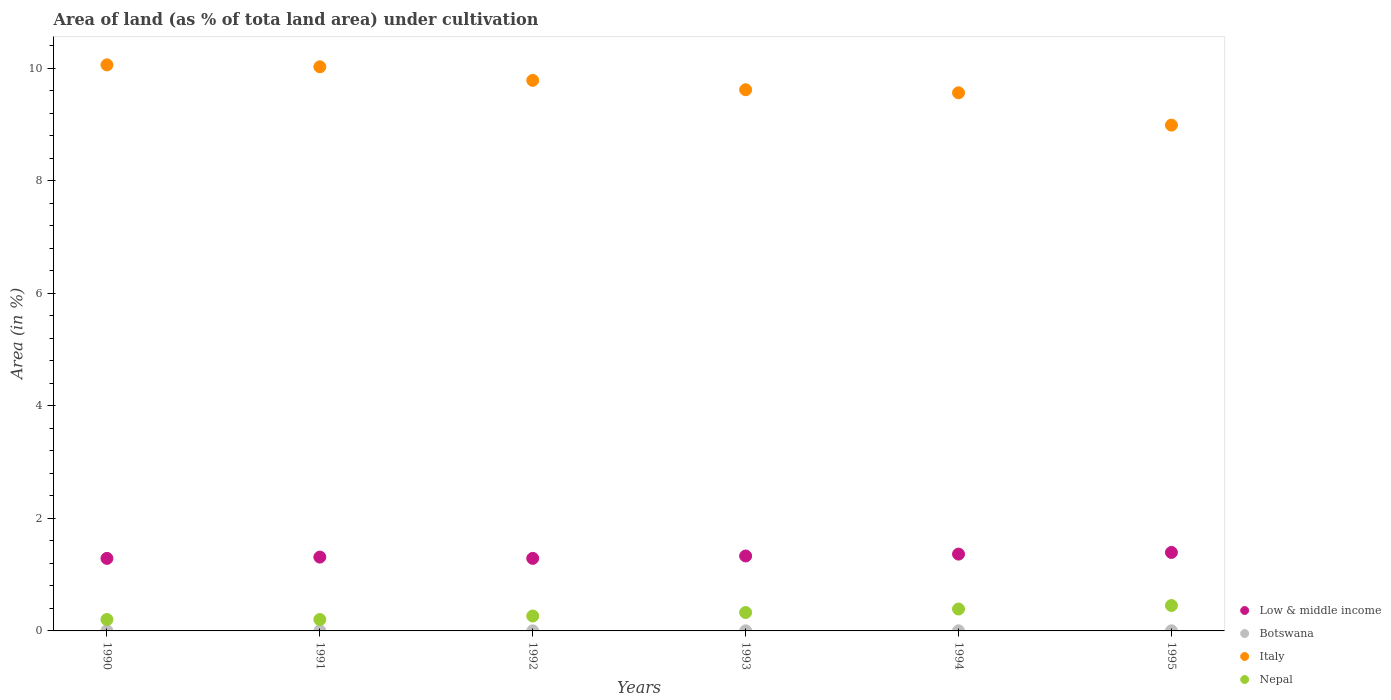How many different coloured dotlines are there?
Make the answer very short. 4. What is the percentage of land under cultivation in Botswana in 1990?
Provide a short and direct response. 0. Across all years, what is the maximum percentage of land under cultivation in Italy?
Keep it short and to the point. 10.06. Across all years, what is the minimum percentage of land under cultivation in Italy?
Your answer should be compact. 8.99. In which year was the percentage of land under cultivation in Nepal maximum?
Offer a very short reply. 1995. In which year was the percentage of land under cultivation in Low & middle income minimum?
Your response must be concise. 1990. What is the total percentage of land under cultivation in Italy in the graph?
Provide a short and direct response. 58.07. What is the difference between the percentage of land under cultivation in Nepal in 1991 and that in 1993?
Offer a terse response. -0.12. What is the difference between the percentage of land under cultivation in Botswana in 1993 and the percentage of land under cultivation in Low & middle income in 1994?
Provide a succinct answer. -1.36. What is the average percentage of land under cultivation in Low & middle income per year?
Provide a short and direct response. 1.33. In the year 1991, what is the difference between the percentage of land under cultivation in Italy and percentage of land under cultivation in Low & middle income?
Provide a short and direct response. 8.72. What is the ratio of the percentage of land under cultivation in Nepal in 1994 to that in 1995?
Give a very brief answer. 0.86. Is the difference between the percentage of land under cultivation in Italy in 1994 and 1995 greater than the difference between the percentage of land under cultivation in Low & middle income in 1994 and 1995?
Provide a succinct answer. Yes. What is the difference between the highest and the second highest percentage of land under cultivation in Nepal?
Give a very brief answer. 0.06. What is the difference between the highest and the lowest percentage of land under cultivation in Botswana?
Provide a succinct answer. 0. Is it the case that in every year, the sum of the percentage of land under cultivation in Nepal and percentage of land under cultivation in Italy  is greater than the sum of percentage of land under cultivation in Low & middle income and percentage of land under cultivation in Botswana?
Your answer should be very brief. Yes. Is it the case that in every year, the sum of the percentage of land under cultivation in Low & middle income and percentage of land under cultivation in Italy  is greater than the percentage of land under cultivation in Nepal?
Your answer should be compact. Yes. How many dotlines are there?
Ensure brevity in your answer.  4. Does the graph contain any zero values?
Give a very brief answer. No. Does the graph contain grids?
Your answer should be compact. No. Where does the legend appear in the graph?
Your answer should be compact. Bottom right. How many legend labels are there?
Keep it short and to the point. 4. How are the legend labels stacked?
Provide a succinct answer. Vertical. What is the title of the graph?
Offer a terse response. Area of land (as % of tota land area) under cultivation. What is the label or title of the X-axis?
Your answer should be compact. Years. What is the label or title of the Y-axis?
Provide a short and direct response. Area (in %). What is the Area (in %) in Low & middle income in 1990?
Your answer should be very brief. 1.29. What is the Area (in %) in Botswana in 1990?
Offer a very short reply. 0. What is the Area (in %) in Italy in 1990?
Your answer should be very brief. 10.06. What is the Area (in %) in Nepal in 1990?
Your answer should be compact. 0.2. What is the Area (in %) of Low & middle income in 1991?
Offer a very short reply. 1.31. What is the Area (in %) in Botswana in 1991?
Give a very brief answer. 0. What is the Area (in %) in Italy in 1991?
Offer a very short reply. 10.03. What is the Area (in %) of Nepal in 1991?
Keep it short and to the point. 0.2. What is the Area (in %) in Low & middle income in 1992?
Your answer should be very brief. 1.29. What is the Area (in %) in Botswana in 1992?
Provide a succinct answer. 0. What is the Area (in %) of Italy in 1992?
Your response must be concise. 9.79. What is the Area (in %) in Nepal in 1992?
Keep it short and to the point. 0.27. What is the Area (in %) of Low & middle income in 1993?
Offer a terse response. 1.33. What is the Area (in %) of Botswana in 1993?
Your response must be concise. 0. What is the Area (in %) in Italy in 1993?
Offer a very short reply. 9.62. What is the Area (in %) in Nepal in 1993?
Give a very brief answer. 0.33. What is the Area (in %) in Low & middle income in 1994?
Make the answer very short. 1.37. What is the Area (in %) of Botswana in 1994?
Keep it short and to the point. 0. What is the Area (in %) of Italy in 1994?
Ensure brevity in your answer.  9.57. What is the Area (in %) of Nepal in 1994?
Offer a very short reply. 0.39. What is the Area (in %) of Low & middle income in 1995?
Make the answer very short. 1.4. What is the Area (in %) of Botswana in 1995?
Offer a very short reply. 0. What is the Area (in %) in Italy in 1995?
Offer a terse response. 8.99. What is the Area (in %) in Nepal in 1995?
Your answer should be very brief. 0.45. Across all years, what is the maximum Area (in %) of Low & middle income?
Offer a very short reply. 1.4. Across all years, what is the maximum Area (in %) in Botswana?
Keep it short and to the point. 0. Across all years, what is the maximum Area (in %) of Italy?
Your answer should be very brief. 10.06. Across all years, what is the maximum Area (in %) in Nepal?
Offer a very short reply. 0.45. Across all years, what is the minimum Area (in %) of Low & middle income?
Offer a terse response. 1.29. Across all years, what is the minimum Area (in %) in Botswana?
Your answer should be compact. 0. Across all years, what is the minimum Area (in %) in Italy?
Your answer should be very brief. 8.99. Across all years, what is the minimum Area (in %) in Nepal?
Your response must be concise. 0.2. What is the total Area (in %) of Low & middle income in the graph?
Provide a short and direct response. 7.99. What is the total Area (in %) in Botswana in the graph?
Your answer should be compact. 0.01. What is the total Area (in %) of Italy in the graph?
Provide a succinct answer. 58.07. What is the total Area (in %) of Nepal in the graph?
Make the answer very short. 1.84. What is the difference between the Area (in %) of Low & middle income in 1990 and that in 1991?
Provide a succinct answer. -0.02. What is the difference between the Area (in %) in Botswana in 1990 and that in 1991?
Ensure brevity in your answer.  0. What is the difference between the Area (in %) in Italy in 1990 and that in 1991?
Keep it short and to the point. 0.03. What is the difference between the Area (in %) of Nepal in 1990 and that in 1991?
Your response must be concise. 0. What is the difference between the Area (in %) of Low & middle income in 1990 and that in 1992?
Your answer should be compact. -0. What is the difference between the Area (in %) in Botswana in 1990 and that in 1992?
Make the answer very short. 0. What is the difference between the Area (in %) in Italy in 1990 and that in 1992?
Your answer should be very brief. 0.28. What is the difference between the Area (in %) of Nepal in 1990 and that in 1992?
Provide a short and direct response. -0.06. What is the difference between the Area (in %) in Low & middle income in 1990 and that in 1993?
Keep it short and to the point. -0.04. What is the difference between the Area (in %) of Italy in 1990 and that in 1993?
Keep it short and to the point. 0.44. What is the difference between the Area (in %) of Nepal in 1990 and that in 1993?
Provide a short and direct response. -0.12. What is the difference between the Area (in %) of Low & middle income in 1990 and that in 1994?
Provide a short and direct response. -0.08. What is the difference between the Area (in %) of Botswana in 1990 and that in 1994?
Give a very brief answer. 0. What is the difference between the Area (in %) in Italy in 1990 and that in 1994?
Offer a very short reply. 0.5. What is the difference between the Area (in %) in Nepal in 1990 and that in 1994?
Offer a terse response. -0.19. What is the difference between the Area (in %) of Low & middle income in 1990 and that in 1995?
Offer a very short reply. -0.11. What is the difference between the Area (in %) of Italy in 1990 and that in 1995?
Offer a terse response. 1.07. What is the difference between the Area (in %) of Nepal in 1990 and that in 1995?
Keep it short and to the point. -0.25. What is the difference between the Area (in %) in Low & middle income in 1991 and that in 1992?
Keep it short and to the point. 0.02. What is the difference between the Area (in %) of Botswana in 1991 and that in 1992?
Provide a short and direct response. 0. What is the difference between the Area (in %) of Italy in 1991 and that in 1992?
Ensure brevity in your answer.  0.24. What is the difference between the Area (in %) in Nepal in 1991 and that in 1992?
Your response must be concise. -0.06. What is the difference between the Area (in %) of Low & middle income in 1991 and that in 1993?
Keep it short and to the point. -0.02. What is the difference between the Area (in %) in Botswana in 1991 and that in 1993?
Give a very brief answer. 0. What is the difference between the Area (in %) in Italy in 1991 and that in 1993?
Offer a very short reply. 0.41. What is the difference between the Area (in %) of Nepal in 1991 and that in 1993?
Offer a very short reply. -0.12. What is the difference between the Area (in %) of Low & middle income in 1991 and that in 1994?
Ensure brevity in your answer.  -0.05. What is the difference between the Area (in %) in Italy in 1991 and that in 1994?
Make the answer very short. 0.46. What is the difference between the Area (in %) of Nepal in 1991 and that in 1994?
Offer a terse response. -0.19. What is the difference between the Area (in %) of Low & middle income in 1991 and that in 1995?
Offer a terse response. -0.08. What is the difference between the Area (in %) in Nepal in 1991 and that in 1995?
Make the answer very short. -0.25. What is the difference between the Area (in %) in Low & middle income in 1992 and that in 1993?
Keep it short and to the point. -0.04. What is the difference between the Area (in %) in Italy in 1992 and that in 1993?
Your answer should be compact. 0.17. What is the difference between the Area (in %) in Nepal in 1992 and that in 1993?
Your response must be concise. -0.06. What is the difference between the Area (in %) in Low & middle income in 1992 and that in 1994?
Your response must be concise. -0.08. What is the difference between the Area (in %) of Botswana in 1992 and that in 1994?
Keep it short and to the point. 0. What is the difference between the Area (in %) in Italy in 1992 and that in 1994?
Your answer should be very brief. 0.22. What is the difference between the Area (in %) of Nepal in 1992 and that in 1994?
Give a very brief answer. -0.12. What is the difference between the Area (in %) of Low & middle income in 1992 and that in 1995?
Provide a succinct answer. -0.11. What is the difference between the Area (in %) of Botswana in 1992 and that in 1995?
Provide a short and direct response. 0. What is the difference between the Area (in %) in Italy in 1992 and that in 1995?
Provide a succinct answer. 0.8. What is the difference between the Area (in %) of Nepal in 1992 and that in 1995?
Offer a terse response. -0.19. What is the difference between the Area (in %) in Low & middle income in 1993 and that in 1994?
Offer a very short reply. -0.03. What is the difference between the Area (in %) in Botswana in 1993 and that in 1994?
Offer a terse response. 0. What is the difference between the Area (in %) in Italy in 1993 and that in 1994?
Make the answer very short. 0.05. What is the difference between the Area (in %) in Nepal in 1993 and that in 1994?
Offer a terse response. -0.06. What is the difference between the Area (in %) of Low & middle income in 1993 and that in 1995?
Keep it short and to the point. -0.06. What is the difference between the Area (in %) in Botswana in 1993 and that in 1995?
Give a very brief answer. 0. What is the difference between the Area (in %) in Italy in 1993 and that in 1995?
Offer a terse response. 0.63. What is the difference between the Area (in %) of Nepal in 1993 and that in 1995?
Make the answer very short. -0.12. What is the difference between the Area (in %) of Low & middle income in 1994 and that in 1995?
Your answer should be very brief. -0.03. What is the difference between the Area (in %) of Italy in 1994 and that in 1995?
Make the answer very short. 0.57. What is the difference between the Area (in %) in Nepal in 1994 and that in 1995?
Provide a short and direct response. -0.06. What is the difference between the Area (in %) of Low & middle income in 1990 and the Area (in %) of Botswana in 1991?
Your response must be concise. 1.29. What is the difference between the Area (in %) in Low & middle income in 1990 and the Area (in %) in Italy in 1991?
Provide a short and direct response. -8.74. What is the difference between the Area (in %) of Low & middle income in 1990 and the Area (in %) of Nepal in 1991?
Your answer should be compact. 1.09. What is the difference between the Area (in %) of Botswana in 1990 and the Area (in %) of Italy in 1991?
Your answer should be compact. -10.03. What is the difference between the Area (in %) in Botswana in 1990 and the Area (in %) in Nepal in 1991?
Offer a terse response. -0.2. What is the difference between the Area (in %) of Italy in 1990 and the Area (in %) of Nepal in 1991?
Your answer should be compact. 9.86. What is the difference between the Area (in %) in Low & middle income in 1990 and the Area (in %) in Botswana in 1992?
Offer a terse response. 1.29. What is the difference between the Area (in %) in Low & middle income in 1990 and the Area (in %) in Italy in 1992?
Provide a short and direct response. -8.5. What is the difference between the Area (in %) in Low & middle income in 1990 and the Area (in %) in Nepal in 1992?
Your answer should be compact. 1.02. What is the difference between the Area (in %) of Botswana in 1990 and the Area (in %) of Italy in 1992?
Ensure brevity in your answer.  -9.79. What is the difference between the Area (in %) of Botswana in 1990 and the Area (in %) of Nepal in 1992?
Keep it short and to the point. -0.26. What is the difference between the Area (in %) of Italy in 1990 and the Area (in %) of Nepal in 1992?
Your answer should be compact. 9.8. What is the difference between the Area (in %) in Low & middle income in 1990 and the Area (in %) in Botswana in 1993?
Your answer should be compact. 1.29. What is the difference between the Area (in %) in Low & middle income in 1990 and the Area (in %) in Italy in 1993?
Give a very brief answer. -8.33. What is the difference between the Area (in %) in Low & middle income in 1990 and the Area (in %) in Nepal in 1993?
Keep it short and to the point. 0.96. What is the difference between the Area (in %) of Botswana in 1990 and the Area (in %) of Italy in 1993?
Your answer should be very brief. -9.62. What is the difference between the Area (in %) of Botswana in 1990 and the Area (in %) of Nepal in 1993?
Your answer should be very brief. -0.33. What is the difference between the Area (in %) in Italy in 1990 and the Area (in %) in Nepal in 1993?
Your response must be concise. 9.74. What is the difference between the Area (in %) in Low & middle income in 1990 and the Area (in %) in Botswana in 1994?
Keep it short and to the point. 1.29. What is the difference between the Area (in %) in Low & middle income in 1990 and the Area (in %) in Italy in 1994?
Ensure brevity in your answer.  -8.28. What is the difference between the Area (in %) of Low & middle income in 1990 and the Area (in %) of Nepal in 1994?
Offer a terse response. 0.9. What is the difference between the Area (in %) in Botswana in 1990 and the Area (in %) in Italy in 1994?
Offer a terse response. -9.57. What is the difference between the Area (in %) in Botswana in 1990 and the Area (in %) in Nepal in 1994?
Make the answer very short. -0.39. What is the difference between the Area (in %) in Italy in 1990 and the Area (in %) in Nepal in 1994?
Your response must be concise. 9.67. What is the difference between the Area (in %) of Low & middle income in 1990 and the Area (in %) of Botswana in 1995?
Your response must be concise. 1.29. What is the difference between the Area (in %) of Low & middle income in 1990 and the Area (in %) of Italy in 1995?
Give a very brief answer. -7.7. What is the difference between the Area (in %) in Low & middle income in 1990 and the Area (in %) in Nepal in 1995?
Provide a short and direct response. 0.84. What is the difference between the Area (in %) in Botswana in 1990 and the Area (in %) in Italy in 1995?
Your answer should be very brief. -8.99. What is the difference between the Area (in %) of Botswana in 1990 and the Area (in %) of Nepal in 1995?
Your answer should be very brief. -0.45. What is the difference between the Area (in %) of Italy in 1990 and the Area (in %) of Nepal in 1995?
Provide a short and direct response. 9.61. What is the difference between the Area (in %) in Low & middle income in 1991 and the Area (in %) in Botswana in 1992?
Keep it short and to the point. 1.31. What is the difference between the Area (in %) of Low & middle income in 1991 and the Area (in %) of Italy in 1992?
Provide a short and direct response. -8.48. What is the difference between the Area (in %) of Low & middle income in 1991 and the Area (in %) of Nepal in 1992?
Keep it short and to the point. 1.05. What is the difference between the Area (in %) in Botswana in 1991 and the Area (in %) in Italy in 1992?
Your answer should be compact. -9.79. What is the difference between the Area (in %) in Botswana in 1991 and the Area (in %) in Nepal in 1992?
Keep it short and to the point. -0.26. What is the difference between the Area (in %) of Italy in 1991 and the Area (in %) of Nepal in 1992?
Ensure brevity in your answer.  9.77. What is the difference between the Area (in %) in Low & middle income in 1991 and the Area (in %) in Botswana in 1993?
Give a very brief answer. 1.31. What is the difference between the Area (in %) of Low & middle income in 1991 and the Area (in %) of Italy in 1993?
Your answer should be very brief. -8.31. What is the difference between the Area (in %) in Low & middle income in 1991 and the Area (in %) in Nepal in 1993?
Provide a short and direct response. 0.99. What is the difference between the Area (in %) of Botswana in 1991 and the Area (in %) of Italy in 1993?
Your answer should be compact. -9.62. What is the difference between the Area (in %) in Botswana in 1991 and the Area (in %) in Nepal in 1993?
Make the answer very short. -0.33. What is the difference between the Area (in %) of Italy in 1991 and the Area (in %) of Nepal in 1993?
Make the answer very short. 9.7. What is the difference between the Area (in %) in Low & middle income in 1991 and the Area (in %) in Botswana in 1994?
Give a very brief answer. 1.31. What is the difference between the Area (in %) of Low & middle income in 1991 and the Area (in %) of Italy in 1994?
Offer a terse response. -8.26. What is the difference between the Area (in %) of Low & middle income in 1991 and the Area (in %) of Nepal in 1994?
Offer a terse response. 0.92. What is the difference between the Area (in %) in Botswana in 1991 and the Area (in %) in Italy in 1994?
Your response must be concise. -9.57. What is the difference between the Area (in %) in Botswana in 1991 and the Area (in %) in Nepal in 1994?
Ensure brevity in your answer.  -0.39. What is the difference between the Area (in %) in Italy in 1991 and the Area (in %) in Nepal in 1994?
Your answer should be very brief. 9.64. What is the difference between the Area (in %) of Low & middle income in 1991 and the Area (in %) of Botswana in 1995?
Provide a succinct answer. 1.31. What is the difference between the Area (in %) in Low & middle income in 1991 and the Area (in %) in Italy in 1995?
Provide a succinct answer. -7.68. What is the difference between the Area (in %) in Low & middle income in 1991 and the Area (in %) in Nepal in 1995?
Provide a succinct answer. 0.86. What is the difference between the Area (in %) of Botswana in 1991 and the Area (in %) of Italy in 1995?
Your response must be concise. -8.99. What is the difference between the Area (in %) in Botswana in 1991 and the Area (in %) in Nepal in 1995?
Your answer should be compact. -0.45. What is the difference between the Area (in %) of Italy in 1991 and the Area (in %) of Nepal in 1995?
Give a very brief answer. 9.58. What is the difference between the Area (in %) in Low & middle income in 1992 and the Area (in %) in Botswana in 1993?
Ensure brevity in your answer.  1.29. What is the difference between the Area (in %) in Low & middle income in 1992 and the Area (in %) in Italy in 1993?
Provide a short and direct response. -8.33. What is the difference between the Area (in %) of Low & middle income in 1992 and the Area (in %) of Nepal in 1993?
Give a very brief answer. 0.96. What is the difference between the Area (in %) of Botswana in 1992 and the Area (in %) of Italy in 1993?
Keep it short and to the point. -9.62. What is the difference between the Area (in %) in Botswana in 1992 and the Area (in %) in Nepal in 1993?
Your answer should be very brief. -0.33. What is the difference between the Area (in %) in Italy in 1992 and the Area (in %) in Nepal in 1993?
Your answer should be compact. 9.46. What is the difference between the Area (in %) in Low & middle income in 1992 and the Area (in %) in Botswana in 1994?
Offer a very short reply. 1.29. What is the difference between the Area (in %) of Low & middle income in 1992 and the Area (in %) of Italy in 1994?
Your answer should be very brief. -8.28. What is the difference between the Area (in %) in Low & middle income in 1992 and the Area (in %) in Nepal in 1994?
Provide a short and direct response. 0.9. What is the difference between the Area (in %) in Botswana in 1992 and the Area (in %) in Italy in 1994?
Offer a very short reply. -9.57. What is the difference between the Area (in %) of Botswana in 1992 and the Area (in %) of Nepal in 1994?
Keep it short and to the point. -0.39. What is the difference between the Area (in %) of Italy in 1992 and the Area (in %) of Nepal in 1994?
Provide a short and direct response. 9.4. What is the difference between the Area (in %) of Low & middle income in 1992 and the Area (in %) of Botswana in 1995?
Ensure brevity in your answer.  1.29. What is the difference between the Area (in %) of Low & middle income in 1992 and the Area (in %) of Italy in 1995?
Your answer should be very brief. -7.7. What is the difference between the Area (in %) in Low & middle income in 1992 and the Area (in %) in Nepal in 1995?
Keep it short and to the point. 0.84. What is the difference between the Area (in %) in Botswana in 1992 and the Area (in %) in Italy in 1995?
Your answer should be very brief. -8.99. What is the difference between the Area (in %) in Botswana in 1992 and the Area (in %) in Nepal in 1995?
Provide a short and direct response. -0.45. What is the difference between the Area (in %) of Italy in 1992 and the Area (in %) of Nepal in 1995?
Your response must be concise. 9.34. What is the difference between the Area (in %) in Low & middle income in 1993 and the Area (in %) in Botswana in 1994?
Your answer should be very brief. 1.33. What is the difference between the Area (in %) of Low & middle income in 1993 and the Area (in %) of Italy in 1994?
Make the answer very short. -8.24. What is the difference between the Area (in %) in Low & middle income in 1993 and the Area (in %) in Nepal in 1994?
Offer a very short reply. 0.94. What is the difference between the Area (in %) in Botswana in 1993 and the Area (in %) in Italy in 1994?
Provide a succinct answer. -9.57. What is the difference between the Area (in %) in Botswana in 1993 and the Area (in %) in Nepal in 1994?
Your answer should be compact. -0.39. What is the difference between the Area (in %) of Italy in 1993 and the Area (in %) of Nepal in 1994?
Ensure brevity in your answer.  9.23. What is the difference between the Area (in %) of Low & middle income in 1993 and the Area (in %) of Botswana in 1995?
Your answer should be compact. 1.33. What is the difference between the Area (in %) in Low & middle income in 1993 and the Area (in %) in Italy in 1995?
Ensure brevity in your answer.  -7.66. What is the difference between the Area (in %) in Low & middle income in 1993 and the Area (in %) in Nepal in 1995?
Provide a succinct answer. 0.88. What is the difference between the Area (in %) of Botswana in 1993 and the Area (in %) of Italy in 1995?
Provide a short and direct response. -8.99. What is the difference between the Area (in %) of Botswana in 1993 and the Area (in %) of Nepal in 1995?
Keep it short and to the point. -0.45. What is the difference between the Area (in %) in Italy in 1993 and the Area (in %) in Nepal in 1995?
Your answer should be compact. 9.17. What is the difference between the Area (in %) of Low & middle income in 1994 and the Area (in %) of Botswana in 1995?
Ensure brevity in your answer.  1.36. What is the difference between the Area (in %) in Low & middle income in 1994 and the Area (in %) in Italy in 1995?
Keep it short and to the point. -7.63. What is the difference between the Area (in %) in Low & middle income in 1994 and the Area (in %) in Nepal in 1995?
Provide a short and direct response. 0.91. What is the difference between the Area (in %) of Botswana in 1994 and the Area (in %) of Italy in 1995?
Your response must be concise. -8.99. What is the difference between the Area (in %) of Botswana in 1994 and the Area (in %) of Nepal in 1995?
Offer a terse response. -0.45. What is the difference between the Area (in %) in Italy in 1994 and the Area (in %) in Nepal in 1995?
Offer a terse response. 9.12. What is the average Area (in %) of Low & middle income per year?
Provide a succinct answer. 1.33. What is the average Area (in %) in Botswana per year?
Your answer should be very brief. 0. What is the average Area (in %) in Italy per year?
Ensure brevity in your answer.  9.68. What is the average Area (in %) in Nepal per year?
Make the answer very short. 0.31. In the year 1990, what is the difference between the Area (in %) of Low & middle income and Area (in %) of Botswana?
Provide a succinct answer. 1.29. In the year 1990, what is the difference between the Area (in %) of Low & middle income and Area (in %) of Italy?
Keep it short and to the point. -8.77. In the year 1990, what is the difference between the Area (in %) of Low & middle income and Area (in %) of Nepal?
Provide a succinct answer. 1.09. In the year 1990, what is the difference between the Area (in %) of Botswana and Area (in %) of Italy?
Make the answer very short. -10.06. In the year 1990, what is the difference between the Area (in %) of Botswana and Area (in %) of Nepal?
Provide a succinct answer. -0.2. In the year 1990, what is the difference between the Area (in %) in Italy and Area (in %) in Nepal?
Your answer should be very brief. 9.86. In the year 1991, what is the difference between the Area (in %) in Low & middle income and Area (in %) in Botswana?
Make the answer very short. 1.31. In the year 1991, what is the difference between the Area (in %) of Low & middle income and Area (in %) of Italy?
Your answer should be compact. -8.72. In the year 1991, what is the difference between the Area (in %) in Low & middle income and Area (in %) in Nepal?
Your response must be concise. 1.11. In the year 1991, what is the difference between the Area (in %) in Botswana and Area (in %) in Italy?
Make the answer very short. -10.03. In the year 1991, what is the difference between the Area (in %) in Botswana and Area (in %) in Nepal?
Offer a terse response. -0.2. In the year 1991, what is the difference between the Area (in %) in Italy and Area (in %) in Nepal?
Make the answer very short. 9.83. In the year 1992, what is the difference between the Area (in %) of Low & middle income and Area (in %) of Botswana?
Make the answer very short. 1.29. In the year 1992, what is the difference between the Area (in %) in Low & middle income and Area (in %) in Italy?
Provide a short and direct response. -8.5. In the year 1992, what is the difference between the Area (in %) in Low & middle income and Area (in %) in Nepal?
Your answer should be compact. 1.02. In the year 1992, what is the difference between the Area (in %) of Botswana and Area (in %) of Italy?
Ensure brevity in your answer.  -9.79. In the year 1992, what is the difference between the Area (in %) of Botswana and Area (in %) of Nepal?
Offer a terse response. -0.26. In the year 1992, what is the difference between the Area (in %) in Italy and Area (in %) in Nepal?
Offer a terse response. 9.52. In the year 1993, what is the difference between the Area (in %) of Low & middle income and Area (in %) of Botswana?
Offer a terse response. 1.33. In the year 1993, what is the difference between the Area (in %) in Low & middle income and Area (in %) in Italy?
Your answer should be compact. -8.29. In the year 1993, what is the difference between the Area (in %) of Low & middle income and Area (in %) of Nepal?
Give a very brief answer. 1. In the year 1993, what is the difference between the Area (in %) of Botswana and Area (in %) of Italy?
Offer a terse response. -9.62. In the year 1993, what is the difference between the Area (in %) of Botswana and Area (in %) of Nepal?
Offer a terse response. -0.33. In the year 1993, what is the difference between the Area (in %) of Italy and Area (in %) of Nepal?
Offer a terse response. 9.29. In the year 1994, what is the difference between the Area (in %) of Low & middle income and Area (in %) of Botswana?
Your answer should be very brief. 1.36. In the year 1994, what is the difference between the Area (in %) of Low & middle income and Area (in %) of Italy?
Provide a short and direct response. -8.2. In the year 1994, what is the difference between the Area (in %) of Low & middle income and Area (in %) of Nepal?
Make the answer very short. 0.98. In the year 1994, what is the difference between the Area (in %) in Botswana and Area (in %) in Italy?
Provide a succinct answer. -9.57. In the year 1994, what is the difference between the Area (in %) in Botswana and Area (in %) in Nepal?
Your response must be concise. -0.39. In the year 1994, what is the difference between the Area (in %) in Italy and Area (in %) in Nepal?
Your answer should be compact. 9.18. In the year 1995, what is the difference between the Area (in %) of Low & middle income and Area (in %) of Botswana?
Keep it short and to the point. 1.39. In the year 1995, what is the difference between the Area (in %) in Low & middle income and Area (in %) in Italy?
Keep it short and to the point. -7.6. In the year 1995, what is the difference between the Area (in %) in Low & middle income and Area (in %) in Nepal?
Your response must be concise. 0.94. In the year 1995, what is the difference between the Area (in %) of Botswana and Area (in %) of Italy?
Your answer should be very brief. -8.99. In the year 1995, what is the difference between the Area (in %) of Botswana and Area (in %) of Nepal?
Your answer should be compact. -0.45. In the year 1995, what is the difference between the Area (in %) of Italy and Area (in %) of Nepal?
Your response must be concise. 8.54. What is the ratio of the Area (in %) in Low & middle income in 1990 to that in 1991?
Make the answer very short. 0.98. What is the ratio of the Area (in %) in Nepal in 1990 to that in 1991?
Offer a terse response. 1. What is the ratio of the Area (in %) of Botswana in 1990 to that in 1992?
Offer a very short reply. 1. What is the ratio of the Area (in %) of Italy in 1990 to that in 1992?
Provide a succinct answer. 1.03. What is the ratio of the Area (in %) of Nepal in 1990 to that in 1992?
Offer a terse response. 0.77. What is the ratio of the Area (in %) of Low & middle income in 1990 to that in 1993?
Provide a short and direct response. 0.97. What is the ratio of the Area (in %) in Italy in 1990 to that in 1993?
Offer a terse response. 1.05. What is the ratio of the Area (in %) in Nepal in 1990 to that in 1993?
Make the answer very short. 0.62. What is the ratio of the Area (in %) of Low & middle income in 1990 to that in 1994?
Keep it short and to the point. 0.94. What is the ratio of the Area (in %) of Botswana in 1990 to that in 1994?
Your answer should be very brief. 1. What is the ratio of the Area (in %) in Italy in 1990 to that in 1994?
Provide a short and direct response. 1.05. What is the ratio of the Area (in %) of Nepal in 1990 to that in 1994?
Provide a short and direct response. 0.52. What is the ratio of the Area (in %) in Low & middle income in 1990 to that in 1995?
Ensure brevity in your answer.  0.92. What is the ratio of the Area (in %) of Italy in 1990 to that in 1995?
Give a very brief answer. 1.12. What is the ratio of the Area (in %) in Nepal in 1990 to that in 1995?
Provide a short and direct response. 0.45. What is the ratio of the Area (in %) of Low & middle income in 1991 to that in 1992?
Ensure brevity in your answer.  1.02. What is the ratio of the Area (in %) in Italy in 1991 to that in 1992?
Your answer should be very brief. 1.02. What is the ratio of the Area (in %) of Nepal in 1991 to that in 1992?
Ensure brevity in your answer.  0.77. What is the ratio of the Area (in %) of Low & middle income in 1991 to that in 1993?
Your answer should be compact. 0.99. What is the ratio of the Area (in %) in Botswana in 1991 to that in 1993?
Offer a terse response. 1. What is the ratio of the Area (in %) in Italy in 1991 to that in 1993?
Provide a succinct answer. 1.04. What is the ratio of the Area (in %) of Nepal in 1991 to that in 1993?
Ensure brevity in your answer.  0.62. What is the ratio of the Area (in %) in Low & middle income in 1991 to that in 1994?
Offer a terse response. 0.96. What is the ratio of the Area (in %) of Italy in 1991 to that in 1994?
Offer a terse response. 1.05. What is the ratio of the Area (in %) of Nepal in 1991 to that in 1994?
Your answer should be compact. 0.52. What is the ratio of the Area (in %) of Low & middle income in 1991 to that in 1995?
Provide a short and direct response. 0.94. What is the ratio of the Area (in %) of Italy in 1991 to that in 1995?
Offer a very short reply. 1.12. What is the ratio of the Area (in %) in Nepal in 1991 to that in 1995?
Offer a terse response. 0.45. What is the ratio of the Area (in %) of Low & middle income in 1992 to that in 1993?
Give a very brief answer. 0.97. What is the ratio of the Area (in %) of Botswana in 1992 to that in 1993?
Ensure brevity in your answer.  1. What is the ratio of the Area (in %) of Italy in 1992 to that in 1993?
Your response must be concise. 1.02. What is the ratio of the Area (in %) of Nepal in 1992 to that in 1993?
Your answer should be compact. 0.81. What is the ratio of the Area (in %) of Low & middle income in 1992 to that in 1994?
Give a very brief answer. 0.94. What is the ratio of the Area (in %) in Botswana in 1992 to that in 1994?
Ensure brevity in your answer.  1. What is the ratio of the Area (in %) in Italy in 1992 to that in 1994?
Offer a very short reply. 1.02. What is the ratio of the Area (in %) in Nepal in 1992 to that in 1994?
Your response must be concise. 0.68. What is the ratio of the Area (in %) in Low & middle income in 1992 to that in 1995?
Your answer should be compact. 0.92. What is the ratio of the Area (in %) in Italy in 1992 to that in 1995?
Give a very brief answer. 1.09. What is the ratio of the Area (in %) in Nepal in 1992 to that in 1995?
Offer a terse response. 0.59. What is the ratio of the Area (in %) of Low & middle income in 1993 to that in 1994?
Your response must be concise. 0.98. What is the ratio of the Area (in %) in Italy in 1993 to that in 1994?
Keep it short and to the point. 1.01. What is the ratio of the Area (in %) in Nepal in 1993 to that in 1994?
Offer a terse response. 0.84. What is the ratio of the Area (in %) of Low & middle income in 1993 to that in 1995?
Your answer should be compact. 0.95. What is the ratio of the Area (in %) in Botswana in 1993 to that in 1995?
Ensure brevity in your answer.  1. What is the ratio of the Area (in %) in Italy in 1993 to that in 1995?
Offer a very short reply. 1.07. What is the ratio of the Area (in %) of Nepal in 1993 to that in 1995?
Your answer should be compact. 0.72. What is the ratio of the Area (in %) of Low & middle income in 1994 to that in 1995?
Offer a very short reply. 0.98. What is the ratio of the Area (in %) in Botswana in 1994 to that in 1995?
Your answer should be compact. 1. What is the ratio of the Area (in %) of Italy in 1994 to that in 1995?
Your answer should be very brief. 1.06. What is the ratio of the Area (in %) in Nepal in 1994 to that in 1995?
Your response must be concise. 0.86. What is the difference between the highest and the second highest Area (in %) of Low & middle income?
Make the answer very short. 0.03. What is the difference between the highest and the second highest Area (in %) in Botswana?
Your answer should be very brief. 0. What is the difference between the highest and the second highest Area (in %) in Italy?
Your response must be concise. 0.03. What is the difference between the highest and the second highest Area (in %) of Nepal?
Your answer should be very brief. 0.06. What is the difference between the highest and the lowest Area (in %) of Low & middle income?
Provide a short and direct response. 0.11. What is the difference between the highest and the lowest Area (in %) in Italy?
Offer a terse response. 1.07. What is the difference between the highest and the lowest Area (in %) of Nepal?
Your response must be concise. 0.25. 